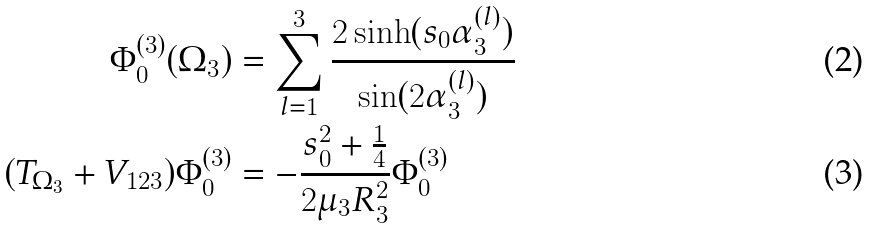<formula> <loc_0><loc_0><loc_500><loc_500>\Phi _ { 0 } ^ { ( 3 ) } ( \Omega _ { 3 } ) & = \sum _ { l = 1 } ^ { 3 } \frac { 2 \sinh ( s _ { 0 } \alpha _ { 3 } ^ { ( l ) } ) } { \sin ( 2 \alpha _ { 3 } ^ { ( l ) } ) } \\ ( T _ { \Omega _ { 3 } } + V _ { 1 2 3 } ) \Phi _ { 0 } ^ { ( 3 ) } & = - \frac { s _ { 0 } ^ { 2 } + \frac { 1 } { 4 } } { 2 \mu _ { 3 } R _ { 3 } ^ { 2 } } \Phi _ { 0 } ^ { ( 3 ) }</formula> 